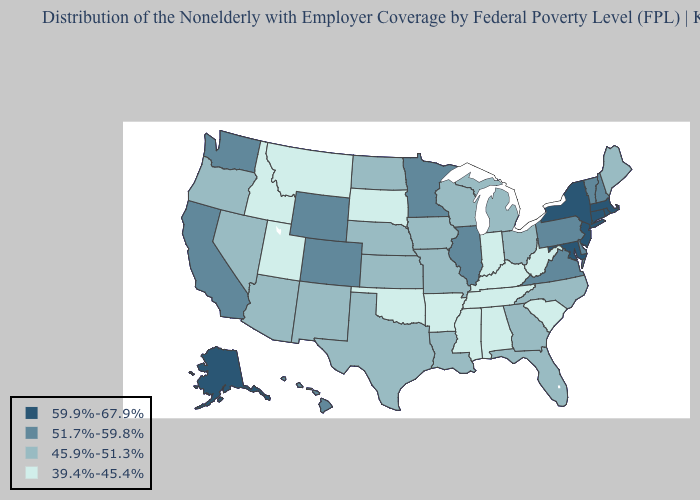Does Nevada have a higher value than Rhode Island?
Answer briefly. No. Among the states that border Wisconsin , which have the highest value?
Answer briefly. Illinois, Minnesota. Name the states that have a value in the range 39.4%-45.4%?
Answer briefly. Alabama, Arkansas, Idaho, Indiana, Kentucky, Mississippi, Montana, Oklahoma, South Carolina, South Dakota, Tennessee, Utah, West Virginia. Does Washington have a lower value than Massachusetts?
Give a very brief answer. Yes. What is the lowest value in the South?
Be succinct. 39.4%-45.4%. What is the value of Washington?
Keep it brief. 51.7%-59.8%. Among the states that border Oregon , which have the highest value?
Short answer required. California, Washington. Among the states that border Tennessee , does Missouri have the lowest value?
Answer briefly. No. What is the value of Vermont?
Answer briefly. 51.7%-59.8%. What is the value of Kentucky?
Answer briefly. 39.4%-45.4%. Does Wyoming have the same value as California?
Answer briefly. Yes. What is the value of Florida?
Answer briefly. 45.9%-51.3%. Does California have the highest value in the West?
Be succinct. No. Among the states that border Pennsylvania , does New Jersey have the lowest value?
Write a very short answer. No. Among the states that border Oklahoma , which have the lowest value?
Give a very brief answer. Arkansas. 